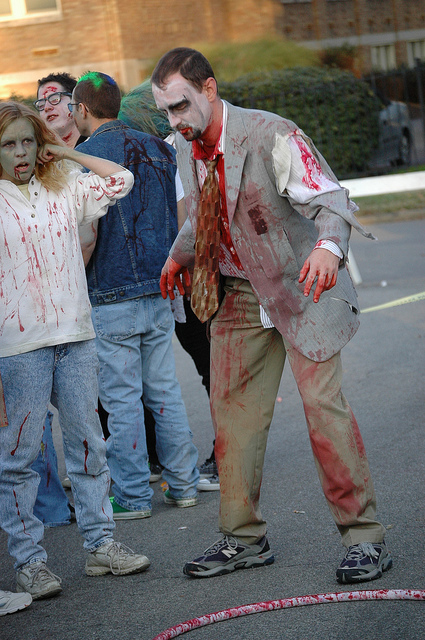Could you describe the expressions and body language of the people? Certainly, the individuals in the image are showcasing expressions and postures typical of zombies in popular culture. Their faces are contorted into unnatural expressions, eyes appear vacant or glaring, and their body language is staggered and stiff, all contributing to a convincing portrayal of the living dead. Do their costumes have any distinguishing features? Yes, the costumes are detailed and distressingly realistic, with torn clothing and fake blood splatters to simulate the gruesome appearance of zombies. This level of detail can enhance the overall experience of the event and entertain onlookers. 